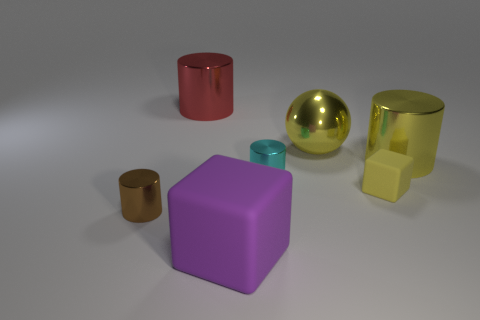What number of large blue rubber cylinders are there?
Provide a short and direct response. 0. How many cubes have the same material as the red thing?
Provide a succinct answer. 0. The other purple object that is the same shape as the small rubber thing is what size?
Ensure brevity in your answer.  Large. What material is the big block?
Your answer should be compact. Rubber. What material is the small thing on the right side of the large yellow shiny object on the left side of the large metal cylinder that is to the right of the purple thing?
Ensure brevity in your answer.  Rubber. What color is the small matte thing that is the same shape as the large matte object?
Ensure brevity in your answer.  Yellow. Do the matte block behind the purple rubber block and the large metal cylinder to the right of the purple thing have the same color?
Give a very brief answer. Yes. Are there more red metal objects to the left of the small cyan metallic thing than tiny cyan spheres?
Offer a terse response. Yes. What number of other objects are the same size as the sphere?
Offer a very short reply. 3. What number of metal objects are both on the right side of the big purple rubber cube and on the left side of the big red thing?
Provide a succinct answer. 0. 